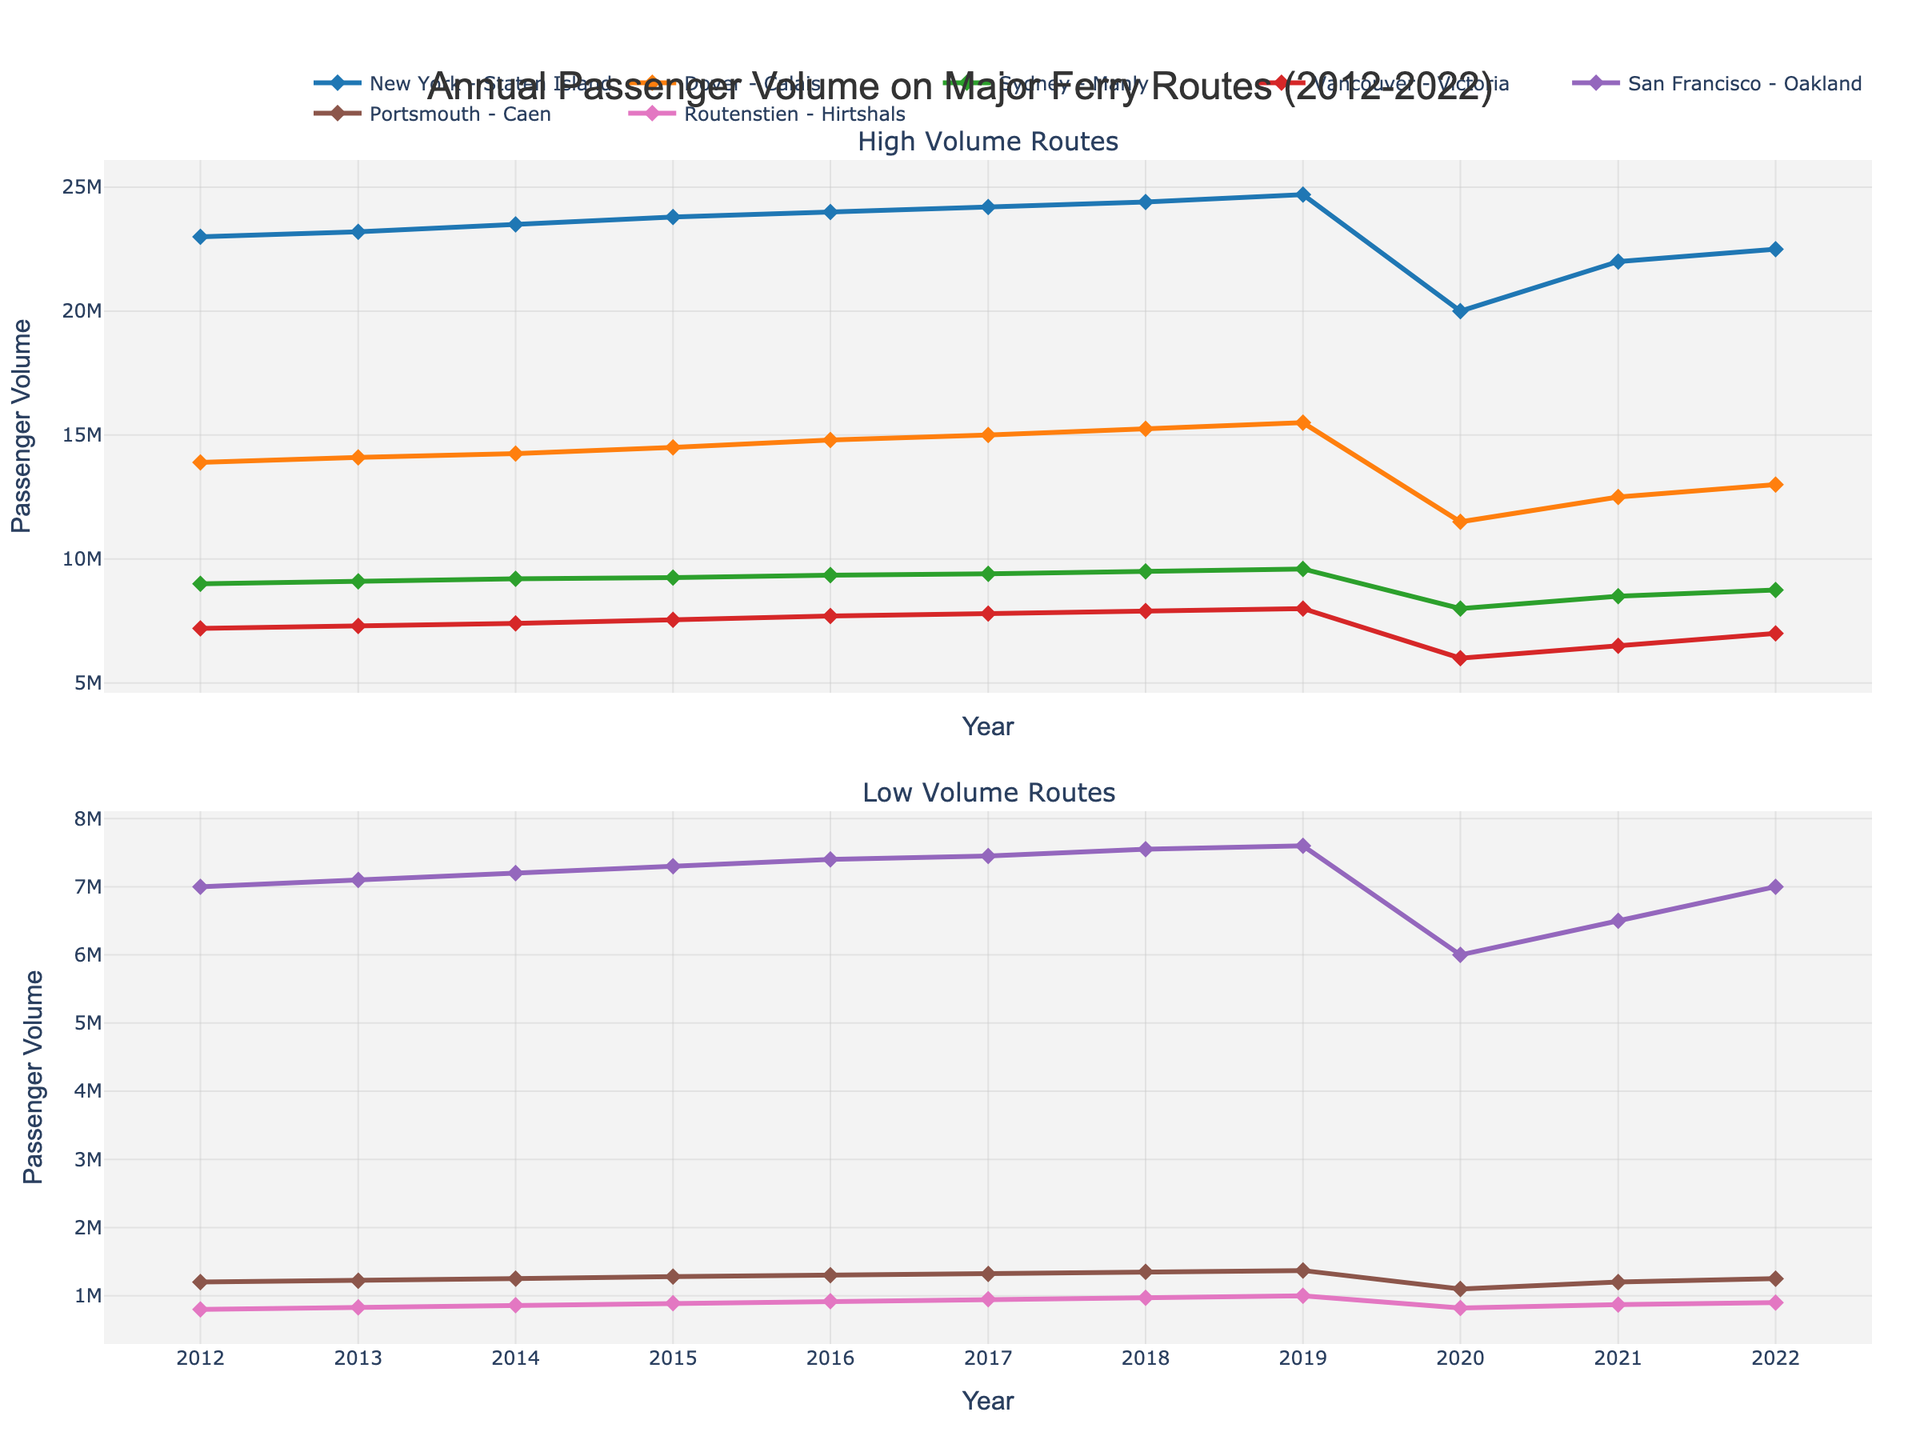What's the title of the plot? The title of the plot is typically found at the top of the figure. In this case, the title reads "Annual Passenger Volume on Major Ferry Routes (2012-2022)".
Answer: Annual Passenger Volume on Major Ferry Routes (2012-2022) What are the years covered in the x-axis? The x-axis generally represents the timeline for the data. Observing the x-axis of the plot, the years range from 2012 to 2022.
Answer: 2012-2022 Which ferry route had the highest passenger volume in 2022? The high-volume routes are represented in the first subplot. By looking at the data points for 2022, "New York - Staten Island" has the highest passenger volume.
Answer: New York - Staten Island What impact did the year 2020 have on the ferry routes in terms of passenger volume? The year 2020 shows a notable decrease in passenger volume across all routes. This can be observed by a sharp drop in the values for that year in the plot.
Answer: Significant decrease How does the passenger volume trend for the "Dover - Calais" route change over the decade? The "Dover - Calais" route starts at around 13,900,000 in 2012 and peaks in 2019 at 15,500,000, then declines in 2020, and partially recovers in the subsequent years. This trend can be observed by following the line's movement in the plot.
Answer: Increases till 2019, then decreases in 2020 Comparison: How does the passenger volume for "San Francisco - Oakland" compare to "Portsmouth - Caen" over the years? Both routes are in the low-volume subplot. "San Francisco - Oakland" generally has a higher passenger volume compared to "Portsmouth - Caen" for most years, observable by comparing the two lines over the timeline.
Answer: Higher Calculate: What is the average passenger volume for the "Sydney - Manly" route from 2012 to 2022? Sum the passenger volumes for each year and divide by the number of years. (9000000 + 9100000 + 9200000 + 9250000 + 9350000 + 9400000 + 9500000 + 9600000 + 8000000 + 8500000 + 8750000) / 11 = 9,218,182.
Answer: 9,218,182 Which ferry route experienced the least decline in passenger volume during 2020? Observing 2020 data points, "Portsmouth - Caen" experienced a smaller decline from 2019 compared to other routes, as its numbers dropped from 1,370,000 to 1,100,000.
Answer: Portsmouth - Caen 